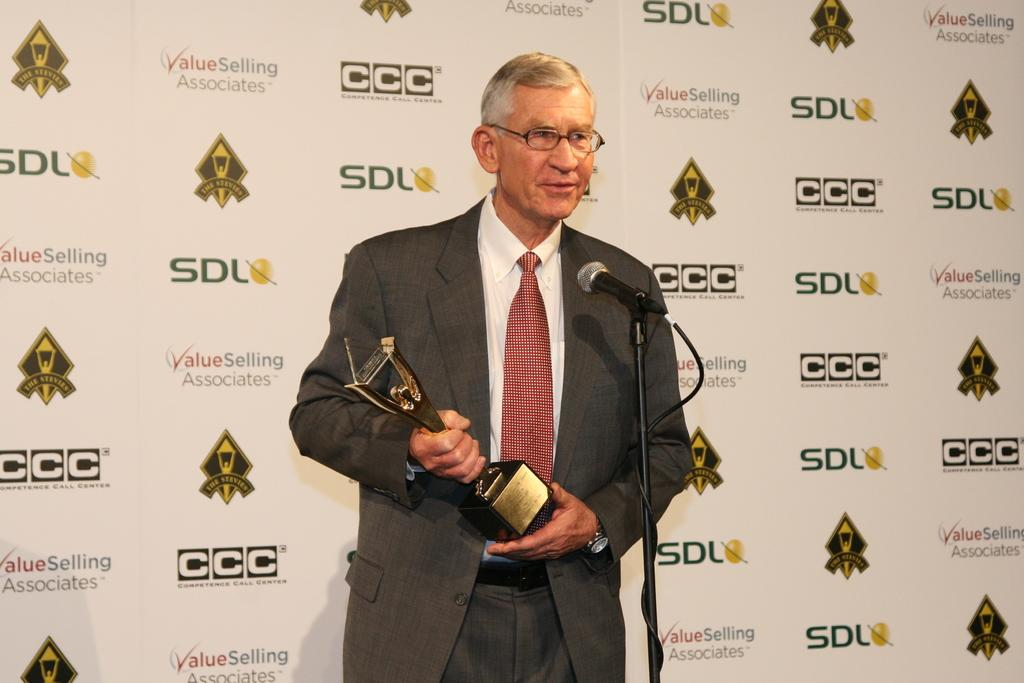Who is the main subject in the image? There is a man in the image. What is the man doing in the image? The man is standing in front of a microphone. What is the man holding in the image? The man is holding a trophy. What accessory is the man wearing in the image? The man is wearing spectacles. What can be seen in the background of the image? There is a hoarding in the background of the image. How many babies are present in the image? There are no babies present in the image. What type of friction is being generated by the man's shoes in the image? There is no information about the man's shoes or any friction in the image. 